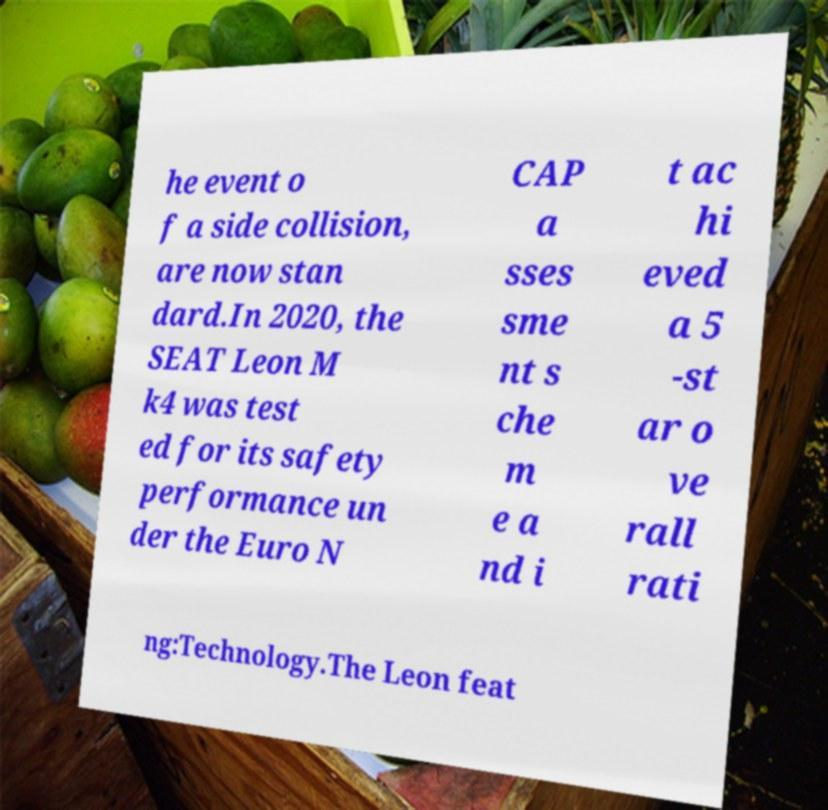There's text embedded in this image that I need extracted. Can you transcribe it verbatim? he event o f a side collision, are now stan dard.In 2020, the SEAT Leon M k4 was test ed for its safety performance un der the Euro N CAP a sses sme nt s che m e a nd i t ac hi eved a 5 -st ar o ve rall rati ng:Technology.The Leon feat 